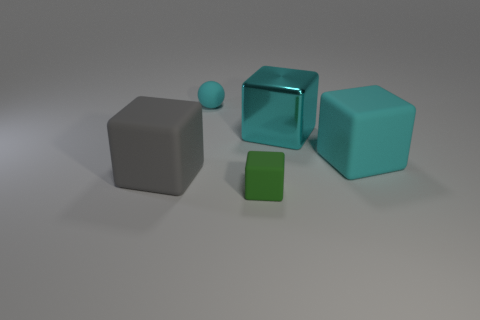Subtract all gray cubes. How many cubes are left? 3 Subtract all tiny green matte cubes. How many cubes are left? 3 Subtract all yellow blocks. Subtract all brown cylinders. How many blocks are left? 4 Add 3 small cyan balls. How many objects exist? 8 Subtract all cubes. How many objects are left? 1 Subtract 1 gray blocks. How many objects are left? 4 Subtract all small cubes. Subtract all large cyan metal spheres. How many objects are left? 4 Add 5 cyan metal objects. How many cyan metal objects are left? 6 Add 4 cyan things. How many cyan things exist? 7 